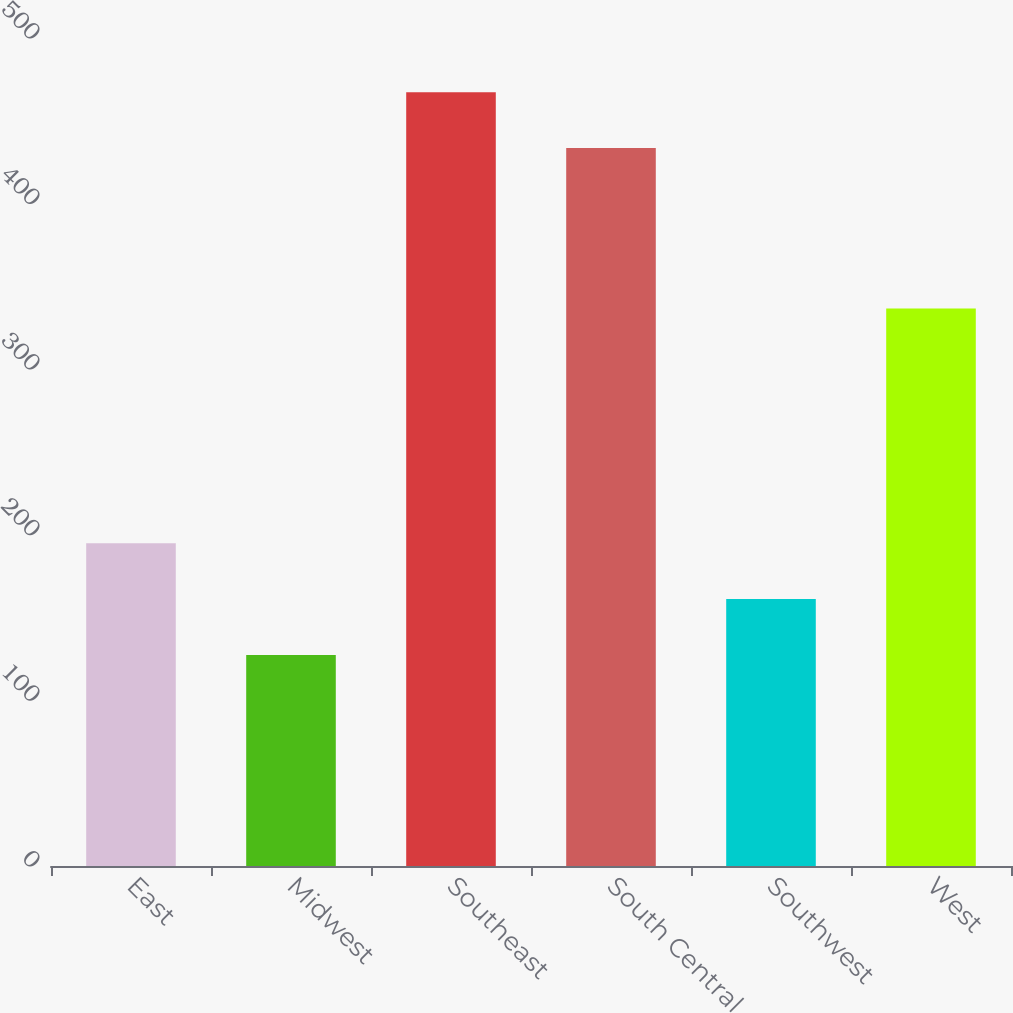Convert chart. <chart><loc_0><loc_0><loc_500><loc_500><bar_chart><fcel>East<fcel>Midwest<fcel>Southeast<fcel>South Central<fcel>Southwest<fcel>West<nl><fcel>194.92<fcel>127.4<fcel>467.26<fcel>433.5<fcel>161.16<fcel>336.6<nl></chart> 